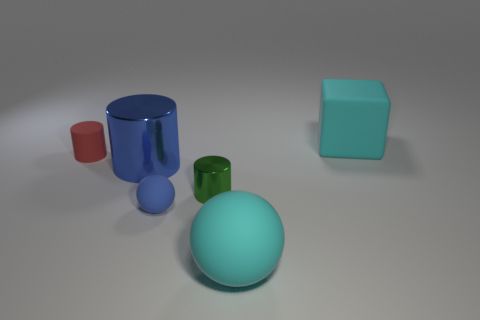Subtract 1 cylinders. How many cylinders are left? 2 Add 2 yellow matte objects. How many objects exist? 8 Subtract 1 red cylinders. How many objects are left? 5 Subtract all spheres. How many objects are left? 4 Subtract all green shiny cylinders. Subtract all large blue metallic things. How many objects are left? 4 Add 1 tiny green shiny cylinders. How many tiny green shiny cylinders are left? 2 Add 4 small objects. How many small objects exist? 7 